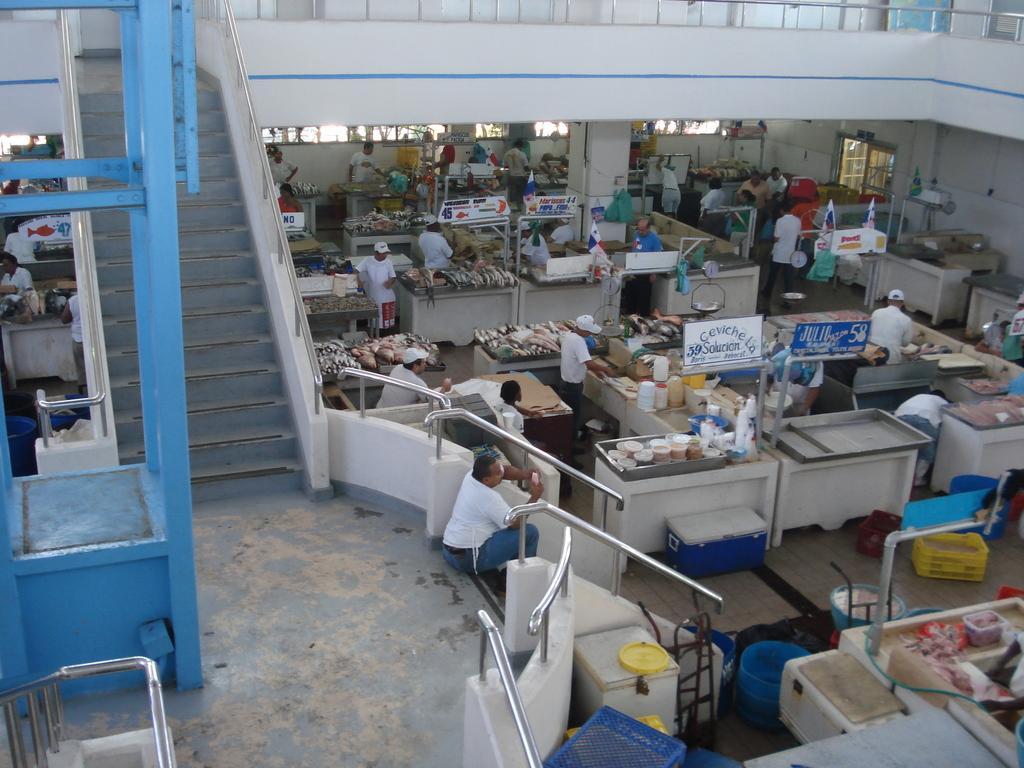In one or two sentences, can you explain what this image depicts? This image consists of many people. It looks like a factory in which there are many fishes. In the front, we can see the stairs and a man sitting on the floor. On the right, we can see many boxes in white color. And there are fishes kept on the table. At the top, we can see a railing. 